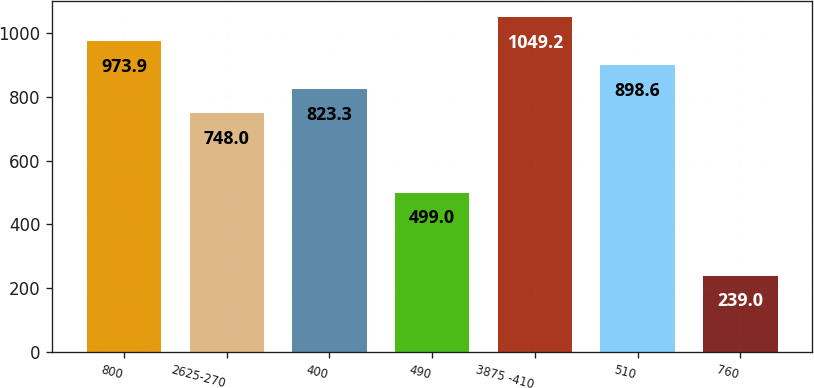<chart> <loc_0><loc_0><loc_500><loc_500><bar_chart><fcel>800<fcel>2625-270<fcel>400<fcel>490<fcel>3875 -410<fcel>510<fcel>760<nl><fcel>973.9<fcel>748<fcel>823.3<fcel>499<fcel>1049.2<fcel>898.6<fcel>239<nl></chart> 